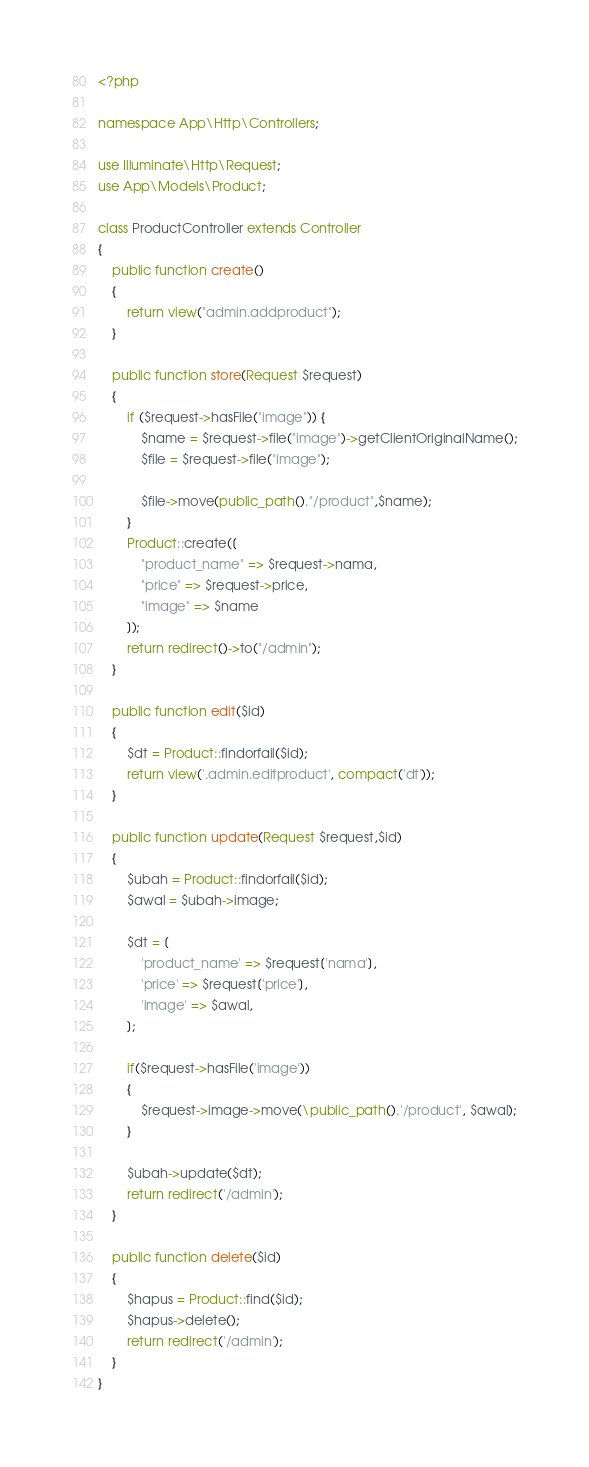Convert code to text. <code><loc_0><loc_0><loc_500><loc_500><_PHP_><?php

namespace App\Http\Controllers;

use Illuminate\Http\Request;
use App\Models\Product;

class ProductController extends Controller
{
    public function create()
    {
        return view("admin.addproduct");
    }

    public function store(Request $request)
    {
        if ($request->hasFile("image")) {
            $name = $request->file("image")->getClientOriginalName();
            $file = $request->file("image");

            $file->move(public_path()."/product",$name);
        }
        Product::create([
            "product_name" => $request->nama,
            "price" => $request->price,
            "image" => $name
        ]);
        return redirect()->to("/admin");
    }

    public function edit($id)
    {
        $dt = Product::findorfail($id);
        return view('.admin.editproduct', compact('dt'));
    }

    public function update(Request $request,$id)
    {
        $ubah = Product::findorfail($id);
        $awal = $ubah->image;

        $dt = [
            'product_name' => $request['nama'],
            'price' => $request['price'],
            'image' => $awal,
        ];

        if($request->hasFile('image'))
        {
            $request->image->move(\public_path().'/product', $awal);
        }

        $ubah->update($dt);
        return redirect('/admin');
    }

    public function delete($id)
    {
        $hapus = Product::find($id);
        $hapus->delete();
        return redirect('/admin');
    }
}
</code> 